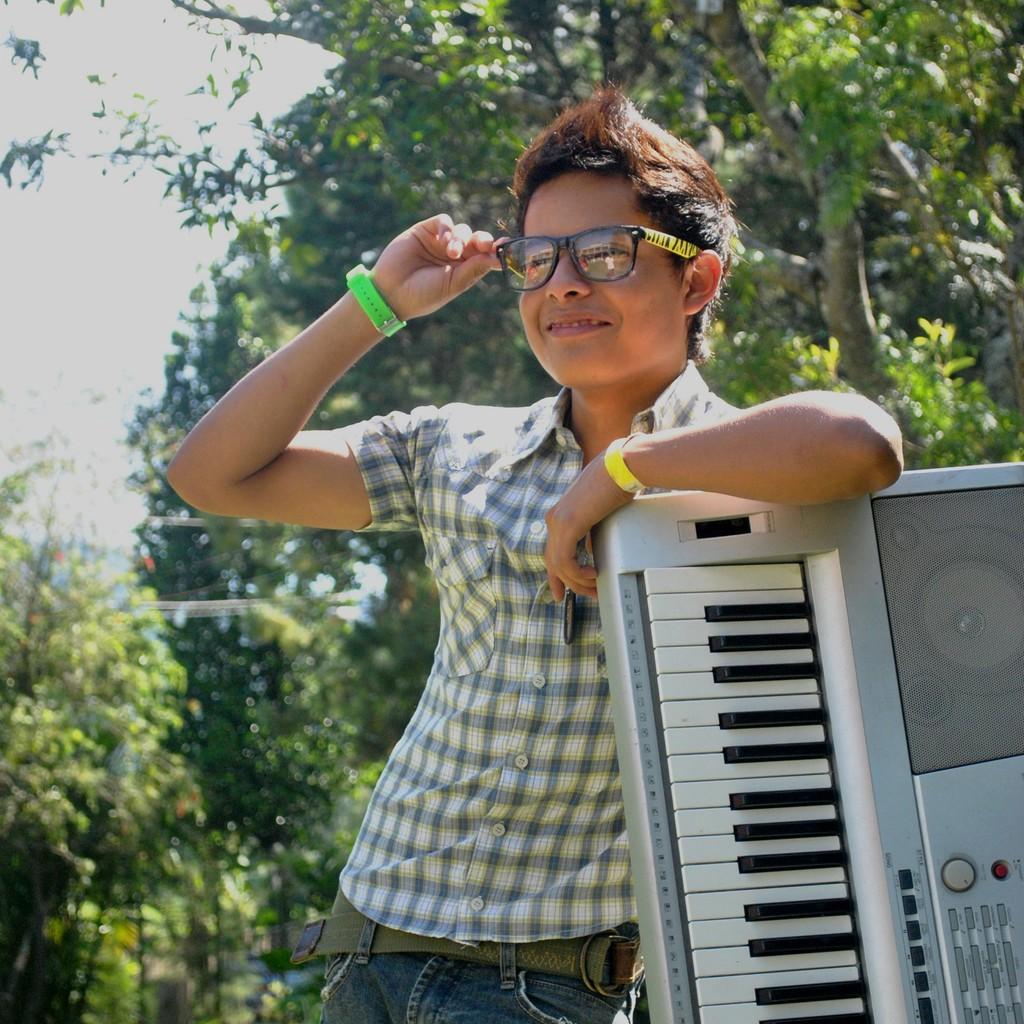Please provide a concise description of this image. This picture is of outside. In the center there is a man wearing shirt, smiling and standing. On the right there is a musical keyboard. In the background there is a sky and trees. 